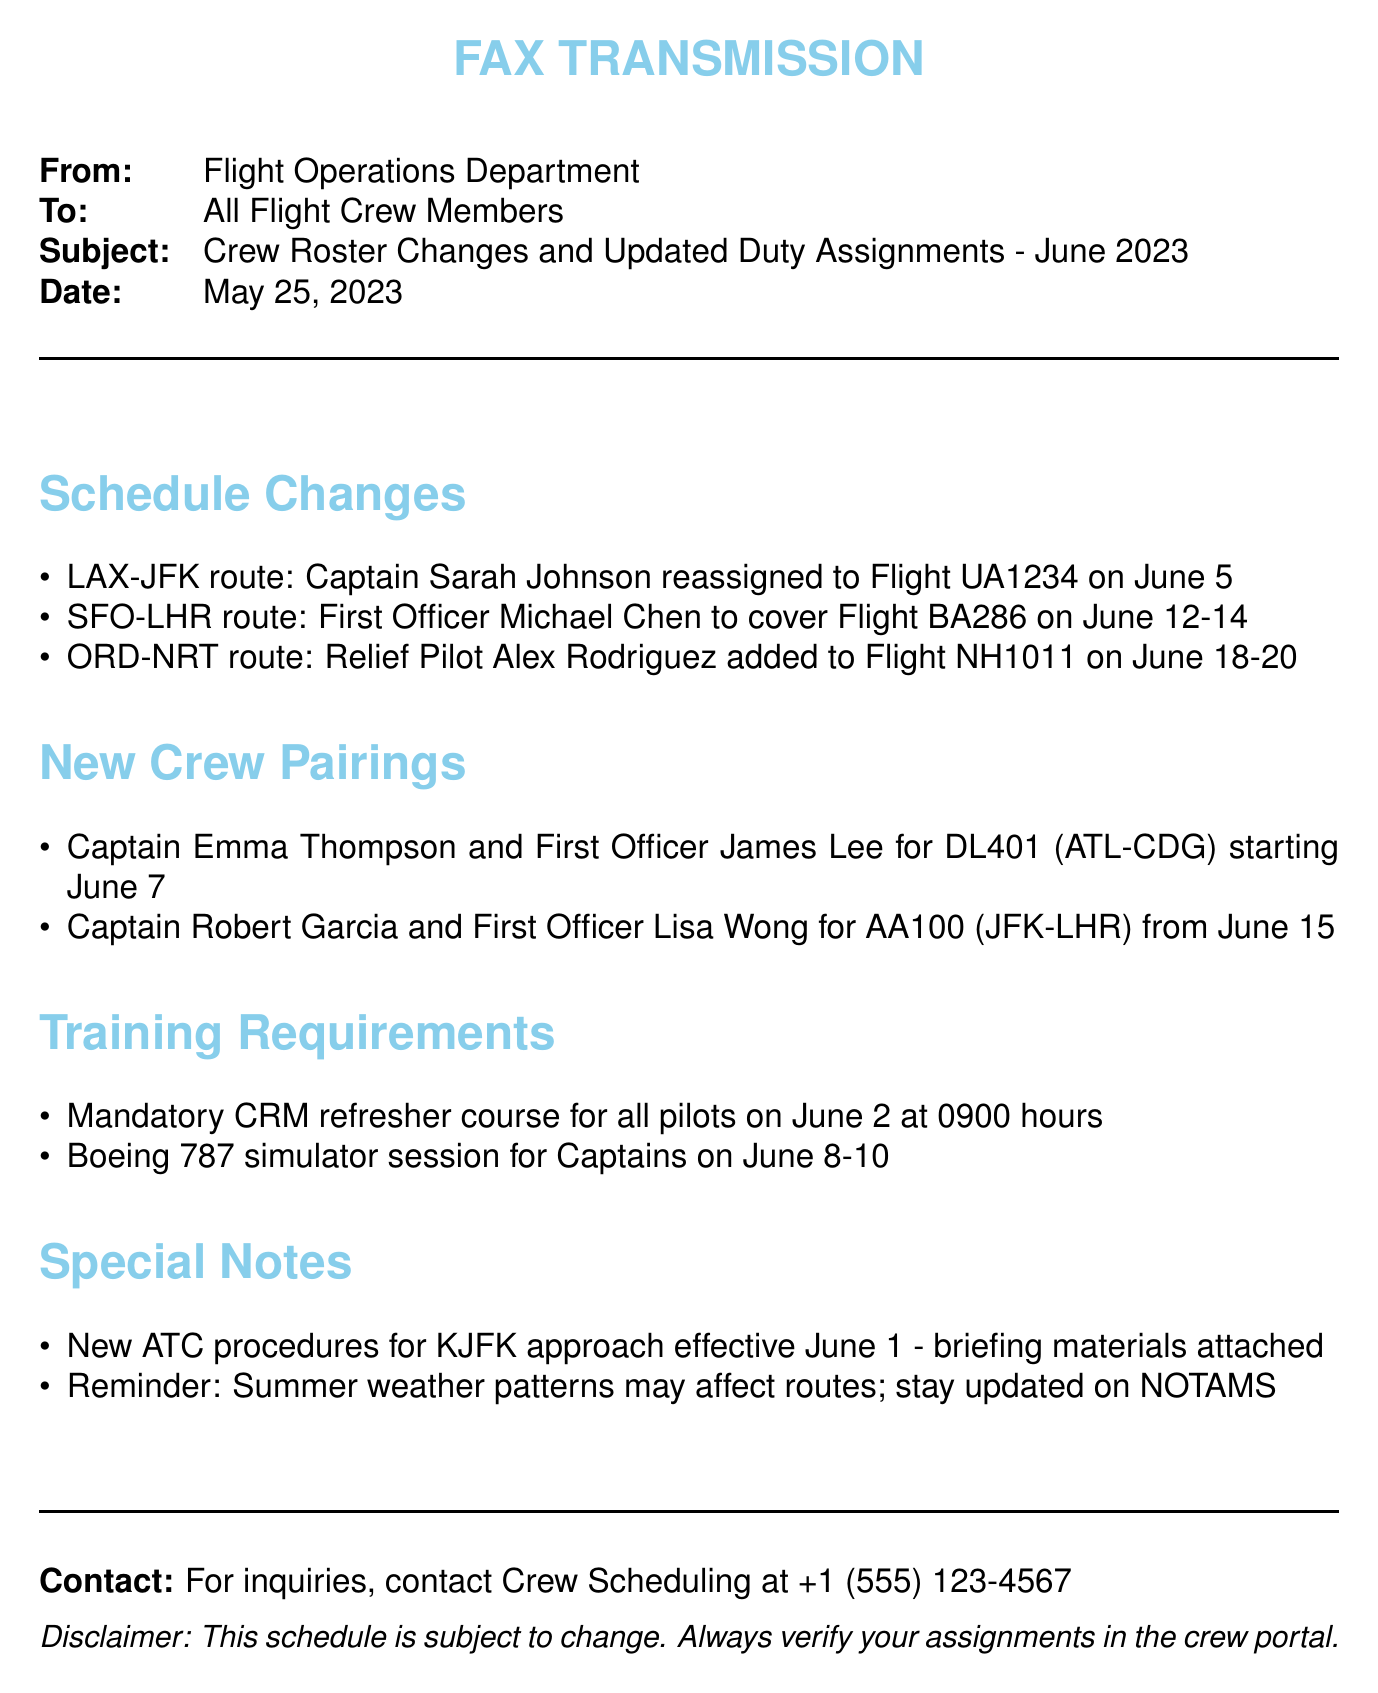What is the subject of the fax? The subject of the fax details the crew roster changes and updated duty assignments for June 2023.
Answer: Crew Roster Changes and Updated Duty Assignments - June 2023 Who is assigned to Flight UA1234? Captain Sarah Johnson is reassigned to Flight UA1234 on June 5 for the LAX-JFK route.
Answer: Captain Sarah Johnson When is the mandatory CRM refresher course scheduled? The course is mentioned to take place on June 2 at 0900 hours in the training requirements section.
Answer: June 2 at 0900 hours Which route is First Officer Michael Chen covering? It specifies that he will cover the SFO-LHR route for Flight BA286 on June 12-14.
Answer: SFO-LHR route What is the special note regarding KJFK approach? The document contains a note regarding the new ATC procedures effective on June 1.
Answer: New ATC procedures for KJFK approach effective June 1 How many days is the Boeing 787 simulator session scheduled? The training requirement states that the simulator session for Captains is on June 8-10, indicating it spans three days.
Answer: Three days Who should be contacted for inquiries? The section for contact details provides information on Crew Scheduling as the point of contact.
Answer: Crew Scheduling What are the names of the pilots for DL401? The document provides the names of the pilots assigned to this flight.
Answer: Captain Emma Thompson and First Officer James Lee 